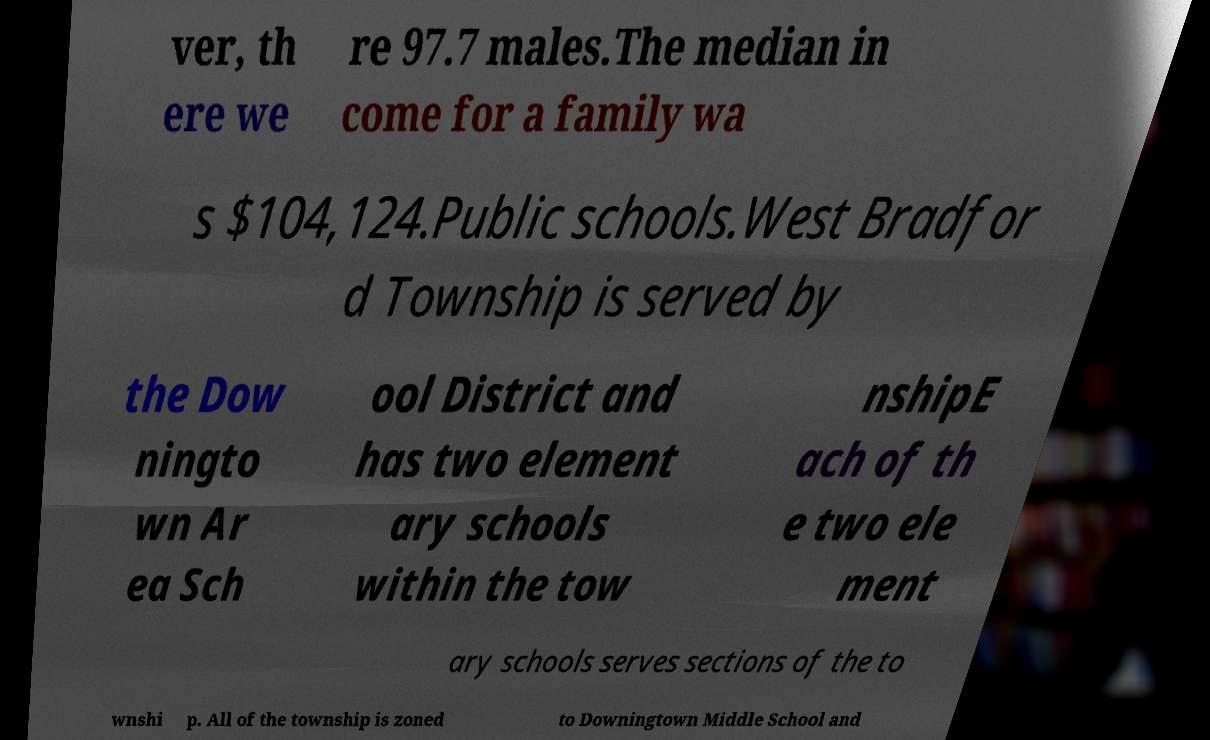Can you accurately transcribe the text from the provided image for me? ver, th ere we re 97.7 males.The median in come for a family wa s $104,124.Public schools.West Bradfor d Township is served by the Dow ningto wn Ar ea Sch ool District and has two element ary schools within the tow nshipE ach of th e two ele ment ary schools serves sections of the to wnshi p. All of the township is zoned to Downingtown Middle School and 